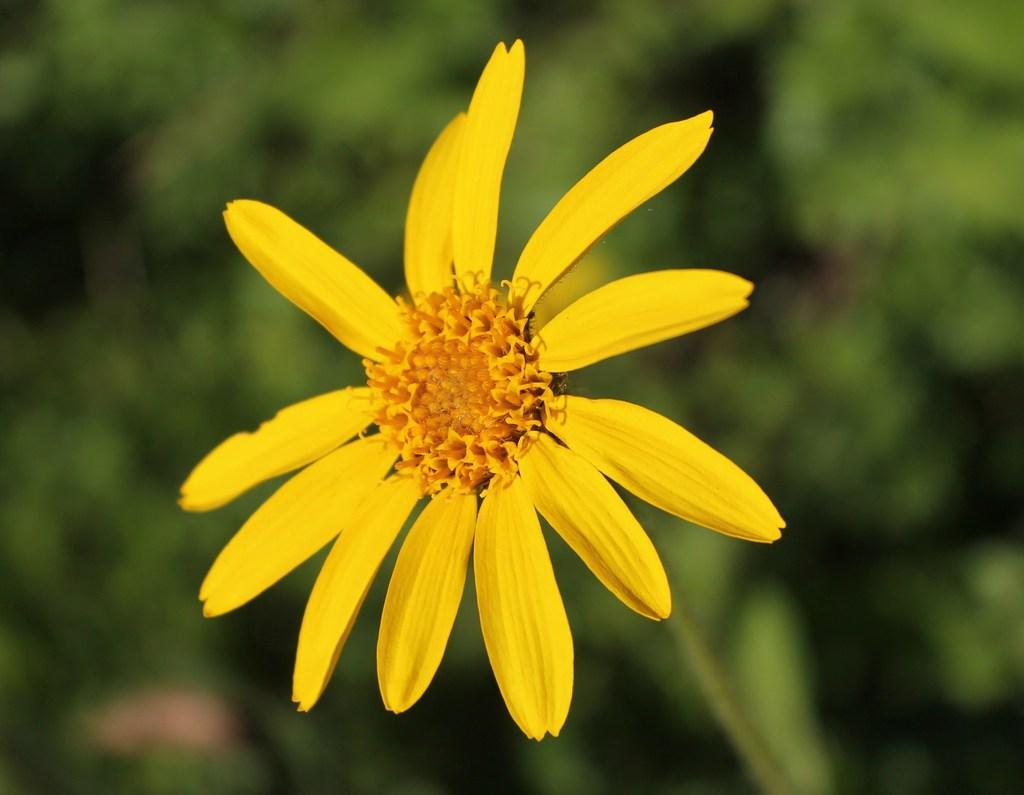What type of flower is in the image? There is a yellow flower in the image. Where is the flower located in relation to the image? The flower is in the front of the image. What color is the background of the image? The background of the image is green and blurred. How many sticks are being used by the beginner in the image? There is no beginner or sticks present in the image; it features a yellow flower in the front with a green and blurred background. 